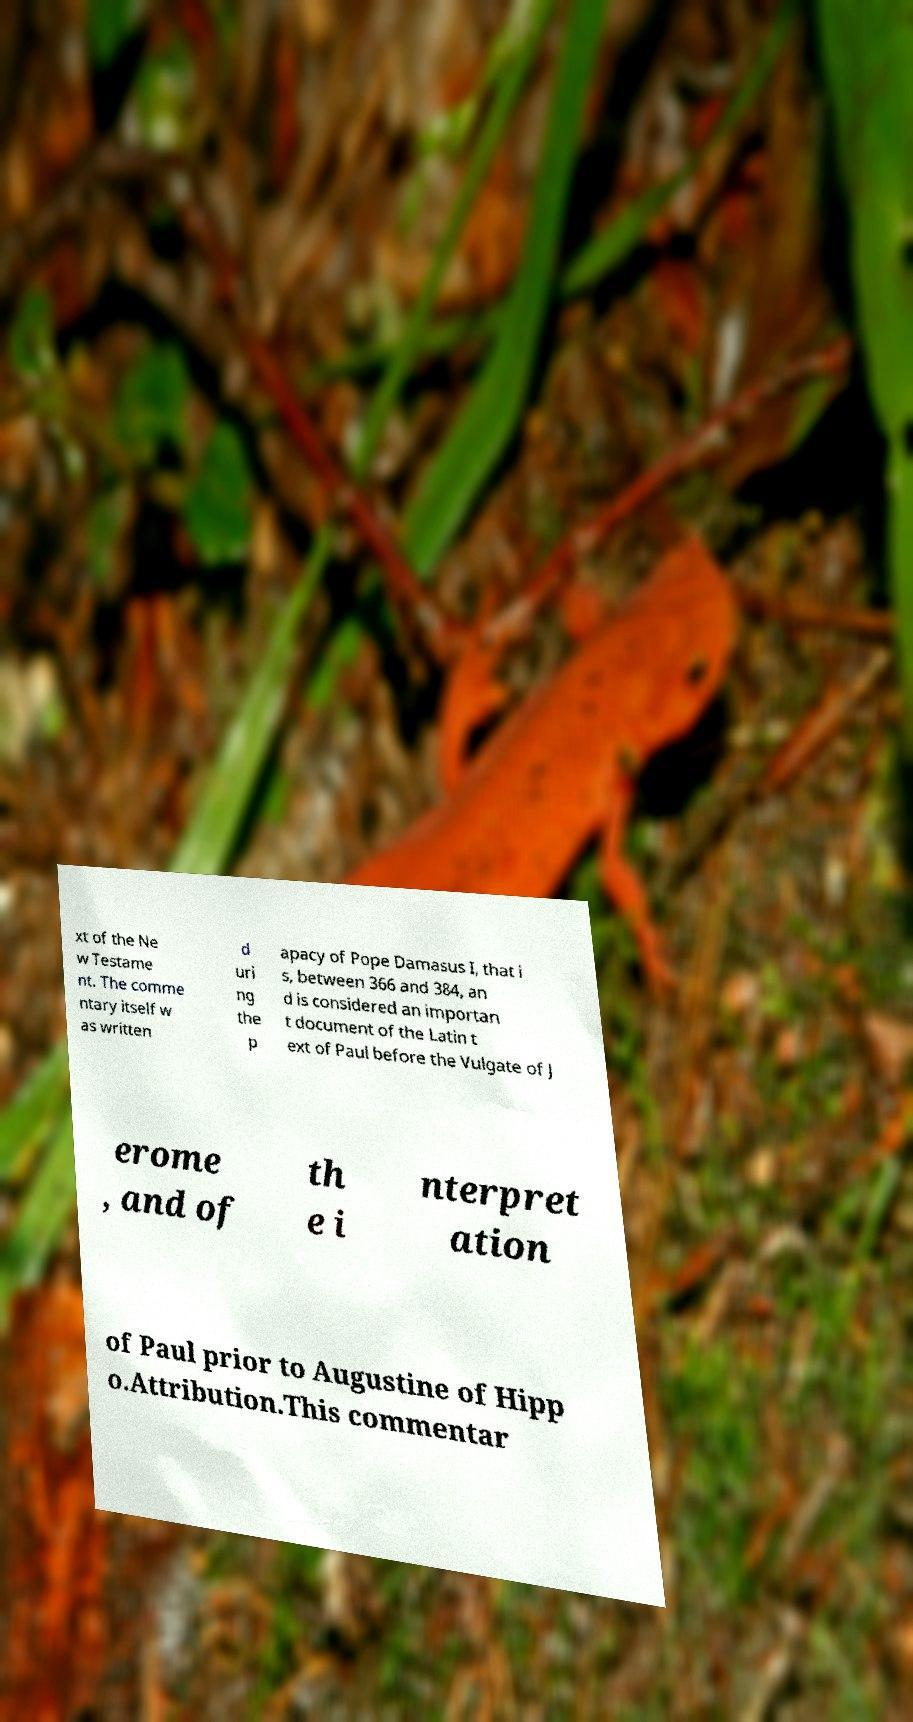Can you accurately transcribe the text from the provided image for me? xt of the Ne w Testame nt. The comme ntary itself w as written d uri ng the p apacy of Pope Damasus I, that i s, between 366 and 384, an d is considered an importan t document of the Latin t ext of Paul before the Vulgate of J erome , and of th e i nterpret ation of Paul prior to Augustine of Hipp o.Attribution.This commentar 